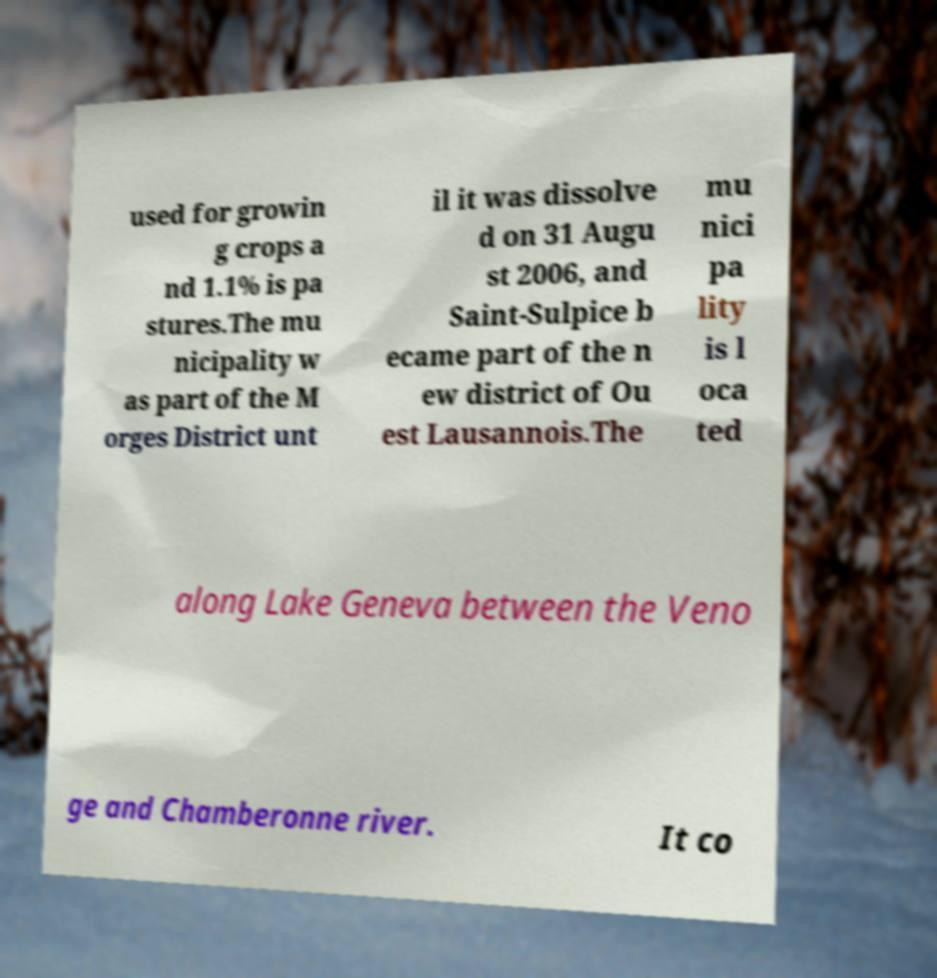Could you extract and type out the text from this image? used for growin g crops a nd 1.1% is pa stures.The mu nicipality w as part of the M orges District unt il it was dissolve d on 31 Augu st 2006, and Saint-Sulpice b ecame part of the n ew district of Ou est Lausannois.The mu nici pa lity is l oca ted along Lake Geneva between the Veno ge and Chamberonne river. It co 